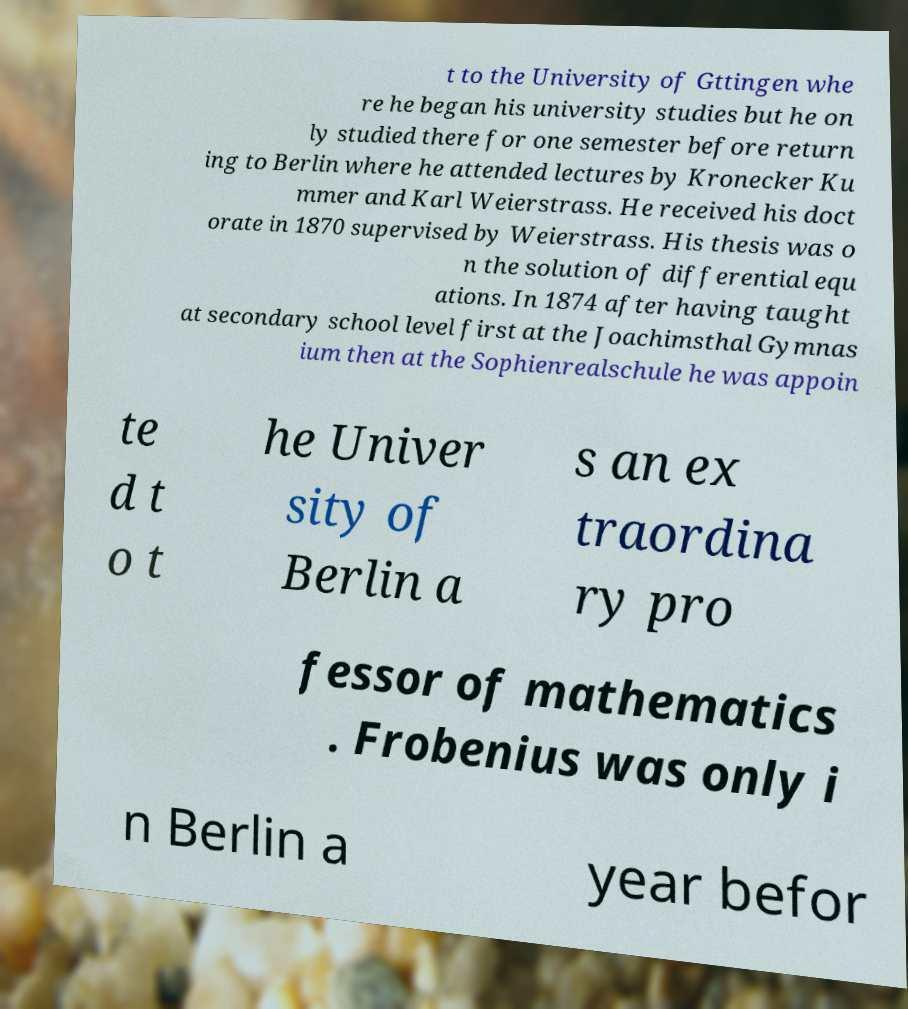There's text embedded in this image that I need extracted. Can you transcribe it verbatim? t to the University of Gttingen whe re he began his university studies but he on ly studied there for one semester before return ing to Berlin where he attended lectures by Kronecker Ku mmer and Karl Weierstrass. He received his doct orate in 1870 supervised by Weierstrass. His thesis was o n the solution of differential equ ations. In 1874 after having taught at secondary school level first at the Joachimsthal Gymnas ium then at the Sophienrealschule he was appoin te d t o t he Univer sity of Berlin a s an ex traordina ry pro fessor of mathematics . Frobenius was only i n Berlin a year befor 